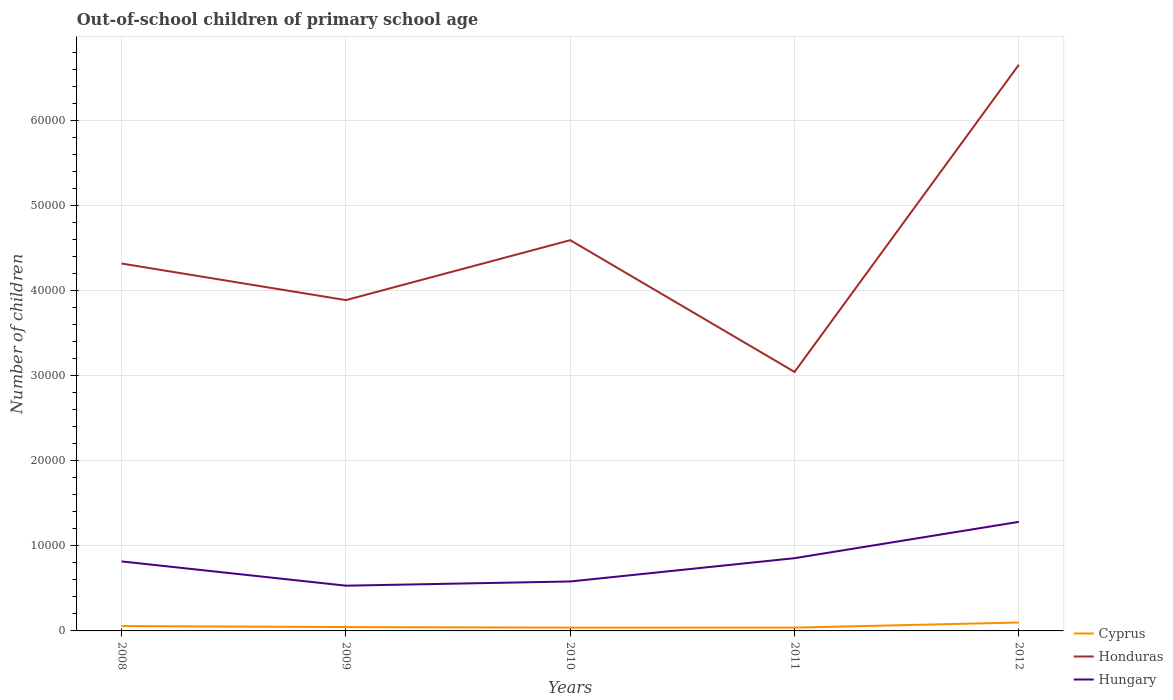How many different coloured lines are there?
Your answer should be compact. 3. Does the line corresponding to Honduras intersect with the line corresponding to Cyprus?
Offer a very short reply. No. Is the number of lines equal to the number of legend labels?
Your answer should be very brief. Yes. Across all years, what is the maximum number of out-of-school children in Hungary?
Offer a very short reply. 5319. What is the total number of out-of-school children in Honduras in the graph?
Your answer should be compact. -3.61e+04. What is the difference between the highest and the second highest number of out-of-school children in Cyprus?
Provide a short and direct response. 602. Is the number of out-of-school children in Honduras strictly greater than the number of out-of-school children in Cyprus over the years?
Provide a succinct answer. No. Does the graph contain any zero values?
Provide a succinct answer. No. Does the graph contain grids?
Offer a very short reply. Yes. How are the legend labels stacked?
Ensure brevity in your answer.  Vertical. What is the title of the graph?
Offer a very short reply. Out-of-school children of primary school age. What is the label or title of the X-axis?
Your answer should be very brief. Years. What is the label or title of the Y-axis?
Make the answer very short. Number of children. What is the Number of children in Cyprus in 2008?
Offer a terse response. 571. What is the Number of children in Honduras in 2008?
Your answer should be very brief. 4.32e+04. What is the Number of children of Hungary in 2008?
Your answer should be compact. 8172. What is the Number of children in Cyprus in 2009?
Ensure brevity in your answer.  453. What is the Number of children of Honduras in 2009?
Offer a very short reply. 3.89e+04. What is the Number of children of Hungary in 2009?
Keep it short and to the point. 5319. What is the Number of children of Cyprus in 2010?
Offer a very short reply. 386. What is the Number of children in Honduras in 2010?
Keep it short and to the point. 4.59e+04. What is the Number of children of Hungary in 2010?
Your answer should be compact. 5814. What is the Number of children in Cyprus in 2011?
Provide a short and direct response. 387. What is the Number of children in Honduras in 2011?
Your answer should be very brief. 3.05e+04. What is the Number of children in Hungary in 2011?
Your answer should be very brief. 8553. What is the Number of children of Cyprus in 2012?
Your answer should be very brief. 988. What is the Number of children in Honduras in 2012?
Provide a succinct answer. 6.66e+04. What is the Number of children of Hungary in 2012?
Make the answer very short. 1.28e+04. Across all years, what is the maximum Number of children of Cyprus?
Your response must be concise. 988. Across all years, what is the maximum Number of children of Honduras?
Your response must be concise. 6.66e+04. Across all years, what is the maximum Number of children in Hungary?
Offer a very short reply. 1.28e+04. Across all years, what is the minimum Number of children of Cyprus?
Give a very brief answer. 386. Across all years, what is the minimum Number of children in Honduras?
Keep it short and to the point. 3.05e+04. Across all years, what is the minimum Number of children of Hungary?
Your response must be concise. 5319. What is the total Number of children of Cyprus in the graph?
Offer a very short reply. 2785. What is the total Number of children of Honduras in the graph?
Give a very brief answer. 2.25e+05. What is the total Number of children in Hungary in the graph?
Provide a short and direct response. 4.07e+04. What is the difference between the Number of children in Cyprus in 2008 and that in 2009?
Your answer should be very brief. 118. What is the difference between the Number of children of Honduras in 2008 and that in 2009?
Offer a very short reply. 4300. What is the difference between the Number of children in Hungary in 2008 and that in 2009?
Offer a very short reply. 2853. What is the difference between the Number of children of Cyprus in 2008 and that in 2010?
Provide a succinct answer. 185. What is the difference between the Number of children in Honduras in 2008 and that in 2010?
Your response must be concise. -2747. What is the difference between the Number of children of Hungary in 2008 and that in 2010?
Give a very brief answer. 2358. What is the difference between the Number of children in Cyprus in 2008 and that in 2011?
Your response must be concise. 184. What is the difference between the Number of children in Honduras in 2008 and that in 2011?
Offer a terse response. 1.27e+04. What is the difference between the Number of children in Hungary in 2008 and that in 2011?
Provide a succinct answer. -381. What is the difference between the Number of children of Cyprus in 2008 and that in 2012?
Your response must be concise. -417. What is the difference between the Number of children of Honduras in 2008 and that in 2012?
Make the answer very short. -2.34e+04. What is the difference between the Number of children in Hungary in 2008 and that in 2012?
Your response must be concise. -4653. What is the difference between the Number of children of Cyprus in 2009 and that in 2010?
Your answer should be compact. 67. What is the difference between the Number of children in Honduras in 2009 and that in 2010?
Ensure brevity in your answer.  -7047. What is the difference between the Number of children of Hungary in 2009 and that in 2010?
Keep it short and to the point. -495. What is the difference between the Number of children of Cyprus in 2009 and that in 2011?
Your response must be concise. 66. What is the difference between the Number of children of Honduras in 2009 and that in 2011?
Give a very brief answer. 8445. What is the difference between the Number of children of Hungary in 2009 and that in 2011?
Your answer should be compact. -3234. What is the difference between the Number of children in Cyprus in 2009 and that in 2012?
Provide a succinct answer. -535. What is the difference between the Number of children of Honduras in 2009 and that in 2012?
Your answer should be very brief. -2.77e+04. What is the difference between the Number of children of Hungary in 2009 and that in 2012?
Your answer should be compact. -7506. What is the difference between the Number of children of Cyprus in 2010 and that in 2011?
Give a very brief answer. -1. What is the difference between the Number of children of Honduras in 2010 and that in 2011?
Your answer should be compact. 1.55e+04. What is the difference between the Number of children of Hungary in 2010 and that in 2011?
Offer a terse response. -2739. What is the difference between the Number of children in Cyprus in 2010 and that in 2012?
Provide a succinct answer. -602. What is the difference between the Number of children in Honduras in 2010 and that in 2012?
Offer a terse response. -2.06e+04. What is the difference between the Number of children of Hungary in 2010 and that in 2012?
Make the answer very short. -7011. What is the difference between the Number of children in Cyprus in 2011 and that in 2012?
Offer a very short reply. -601. What is the difference between the Number of children of Honduras in 2011 and that in 2012?
Provide a succinct answer. -3.61e+04. What is the difference between the Number of children of Hungary in 2011 and that in 2012?
Keep it short and to the point. -4272. What is the difference between the Number of children of Cyprus in 2008 and the Number of children of Honduras in 2009?
Your answer should be compact. -3.83e+04. What is the difference between the Number of children in Cyprus in 2008 and the Number of children in Hungary in 2009?
Offer a very short reply. -4748. What is the difference between the Number of children of Honduras in 2008 and the Number of children of Hungary in 2009?
Provide a succinct answer. 3.79e+04. What is the difference between the Number of children in Cyprus in 2008 and the Number of children in Honduras in 2010?
Your response must be concise. -4.54e+04. What is the difference between the Number of children in Cyprus in 2008 and the Number of children in Hungary in 2010?
Your response must be concise. -5243. What is the difference between the Number of children in Honduras in 2008 and the Number of children in Hungary in 2010?
Offer a terse response. 3.74e+04. What is the difference between the Number of children in Cyprus in 2008 and the Number of children in Honduras in 2011?
Ensure brevity in your answer.  -2.99e+04. What is the difference between the Number of children of Cyprus in 2008 and the Number of children of Hungary in 2011?
Ensure brevity in your answer.  -7982. What is the difference between the Number of children of Honduras in 2008 and the Number of children of Hungary in 2011?
Keep it short and to the point. 3.46e+04. What is the difference between the Number of children in Cyprus in 2008 and the Number of children in Honduras in 2012?
Offer a terse response. -6.60e+04. What is the difference between the Number of children of Cyprus in 2008 and the Number of children of Hungary in 2012?
Your answer should be very brief. -1.23e+04. What is the difference between the Number of children in Honduras in 2008 and the Number of children in Hungary in 2012?
Keep it short and to the point. 3.04e+04. What is the difference between the Number of children of Cyprus in 2009 and the Number of children of Honduras in 2010?
Your answer should be compact. -4.55e+04. What is the difference between the Number of children in Cyprus in 2009 and the Number of children in Hungary in 2010?
Give a very brief answer. -5361. What is the difference between the Number of children in Honduras in 2009 and the Number of children in Hungary in 2010?
Give a very brief answer. 3.31e+04. What is the difference between the Number of children of Cyprus in 2009 and the Number of children of Hungary in 2011?
Your answer should be compact. -8100. What is the difference between the Number of children of Honduras in 2009 and the Number of children of Hungary in 2011?
Make the answer very short. 3.03e+04. What is the difference between the Number of children in Cyprus in 2009 and the Number of children in Honduras in 2012?
Offer a very short reply. -6.61e+04. What is the difference between the Number of children of Cyprus in 2009 and the Number of children of Hungary in 2012?
Give a very brief answer. -1.24e+04. What is the difference between the Number of children of Honduras in 2009 and the Number of children of Hungary in 2012?
Provide a succinct answer. 2.61e+04. What is the difference between the Number of children of Cyprus in 2010 and the Number of children of Honduras in 2011?
Offer a terse response. -3.01e+04. What is the difference between the Number of children in Cyprus in 2010 and the Number of children in Hungary in 2011?
Provide a short and direct response. -8167. What is the difference between the Number of children in Honduras in 2010 and the Number of children in Hungary in 2011?
Make the answer very short. 3.74e+04. What is the difference between the Number of children in Cyprus in 2010 and the Number of children in Honduras in 2012?
Your response must be concise. -6.62e+04. What is the difference between the Number of children of Cyprus in 2010 and the Number of children of Hungary in 2012?
Provide a short and direct response. -1.24e+04. What is the difference between the Number of children in Honduras in 2010 and the Number of children in Hungary in 2012?
Offer a very short reply. 3.31e+04. What is the difference between the Number of children of Cyprus in 2011 and the Number of children of Honduras in 2012?
Provide a short and direct response. -6.62e+04. What is the difference between the Number of children in Cyprus in 2011 and the Number of children in Hungary in 2012?
Your answer should be compact. -1.24e+04. What is the difference between the Number of children of Honduras in 2011 and the Number of children of Hungary in 2012?
Ensure brevity in your answer.  1.76e+04. What is the average Number of children in Cyprus per year?
Your answer should be very brief. 557. What is the average Number of children of Honduras per year?
Your response must be concise. 4.50e+04. What is the average Number of children in Hungary per year?
Offer a very short reply. 8136.6. In the year 2008, what is the difference between the Number of children of Cyprus and Number of children of Honduras?
Provide a short and direct response. -4.26e+04. In the year 2008, what is the difference between the Number of children in Cyprus and Number of children in Hungary?
Give a very brief answer. -7601. In the year 2008, what is the difference between the Number of children of Honduras and Number of children of Hungary?
Your response must be concise. 3.50e+04. In the year 2009, what is the difference between the Number of children in Cyprus and Number of children in Honduras?
Keep it short and to the point. -3.84e+04. In the year 2009, what is the difference between the Number of children of Cyprus and Number of children of Hungary?
Provide a succinct answer. -4866. In the year 2009, what is the difference between the Number of children of Honduras and Number of children of Hungary?
Ensure brevity in your answer.  3.36e+04. In the year 2010, what is the difference between the Number of children in Cyprus and Number of children in Honduras?
Your response must be concise. -4.56e+04. In the year 2010, what is the difference between the Number of children of Cyprus and Number of children of Hungary?
Ensure brevity in your answer.  -5428. In the year 2010, what is the difference between the Number of children of Honduras and Number of children of Hungary?
Offer a very short reply. 4.01e+04. In the year 2011, what is the difference between the Number of children of Cyprus and Number of children of Honduras?
Ensure brevity in your answer.  -3.01e+04. In the year 2011, what is the difference between the Number of children in Cyprus and Number of children in Hungary?
Make the answer very short. -8166. In the year 2011, what is the difference between the Number of children in Honduras and Number of children in Hungary?
Ensure brevity in your answer.  2.19e+04. In the year 2012, what is the difference between the Number of children in Cyprus and Number of children in Honduras?
Offer a terse response. -6.56e+04. In the year 2012, what is the difference between the Number of children in Cyprus and Number of children in Hungary?
Make the answer very short. -1.18e+04. In the year 2012, what is the difference between the Number of children in Honduras and Number of children in Hungary?
Your answer should be compact. 5.38e+04. What is the ratio of the Number of children in Cyprus in 2008 to that in 2009?
Ensure brevity in your answer.  1.26. What is the ratio of the Number of children of Honduras in 2008 to that in 2009?
Offer a very short reply. 1.11. What is the ratio of the Number of children in Hungary in 2008 to that in 2009?
Offer a very short reply. 1.54. What is the ratio of the Number of children of Cyprus in 2008 to that in 2010?
Offer a very short reply. 1.48. What is the ratio of the Number of children in Honduras in 2008 to that in 2010?
Offer a very short reply. 0.94. What is the ratio of the Number of children in Hungary in 2008 to that in 2010?
Ensure brevity in your answer.  1.41. What is the ratio of the Number of children of Cyprus in 2008 to that in 2011?
Keep it short and to the point. 1.48. What is the ratio of the Number of children of Honduras in 2008 to that in 2011?
Offer a terse response. 1.42. What is the ratio of the Number of children in Hungary in 2008 to that in 2011?
Make the answer very short. 0.96. What is the ratio of the Number of children in Cyprus in 2008 to that in 2012?
Provide a short and direct response. 0.58. What is the ratio of the Number of children in Honduras in 2008 to that in 2012?
Ensure brevity in your answer.  0.65. What is the ratio of the Number of children of Hungary in 2008 to that in 2012?
Offer a very short reply. 0.64. What is the ratio of the Number of children in Cyprus in 2009 to that in 2010?
Make the answer very short. 1.17. What is the ratio of the Number of children of Honduras in 2009 to that in 2010?
Ensure brevity in your answer.  0.85. What is the ratio of the Number of children of Hungary in 2009 to that in 2010?
Make the answer very short. 0.91. What is the ratio of the Number of children in Cyprus in 2009 to that in 2011?
Offer a terse response. 1.17. What is the ratio of the Number of children of Honduras in 2009 to that in 2011?
Give a very brief answer. 1.28. What is the ratio of the Number of children in Hungary in 2009 to that in 2011?
Offer a very short reply. 0.62. What is the ratio of the Number of children of Cyprus in 2009 to that in 2012?
Keep it short and to the point. 0.46. What is the ratio of the Number of children in Honduras in 2009 to that in 2012?
Provide a succinct answer. 0.58. What is the ratio of the Number of children in Hungary in 2009 to that in 2012?
Offer a terse response. 0.41. What is the ratio of the Number of children of Cyprus in 2010 to that in 2011?
Make the answer very short. 1. What is the ratio of the Number of children in Honduras in 2010 to that in 2011?
Offer a terse response. 1.51. What is the ratio of the Number of children of Hungary in 2010 to that in 2011?
Give a very brief answer. 0.68. What is the ratio of the Number of children of Cyprus in 2010 to that in 2012?
Provide a short and direct response. 0.39. What is the ratio of the Number of children in Honduras in 2010 to that in 2012?
Your answer should be compact. 0.69. What is the ratio of the Number of children in Hungary in 2010 to that in 2012?
Provide a short and direct response. 0.45. What is the ratio of the Number of children of Cyprus in 2011 to that in 2012?
Keep it short and to the point. 0.39. What is the ratio of the Number of children of Honduras in 2011 to that in 2012?
Your answer should be compact. 0.46. What is the ratio of the Number of children in Hungary in 2011 to that in 2012?
Your response must be concise. 0.67. What is the difference between the highest and the second highest Number of children in Cyprus?
Keep it short and to the point. 417. What is the difference between the highest and the second highest Number of children of Honduras?
Ensure brevity in your answer.  2.06e+04. What is the difference between the highest and the second highest Number of children in Hungary?
Offer a very short reply. 4272. What is the difference between the highest and the lowest Number of children in Cyprus?
Your response must be concise. 602. What is the difference between the highest and the lowest Number of children in Honduras?
Provide a succinct answer. 3.61e+04. What is the difference between the highest and the lowest Number of children of Hungary?
Provide a succinct answer. 7506. 